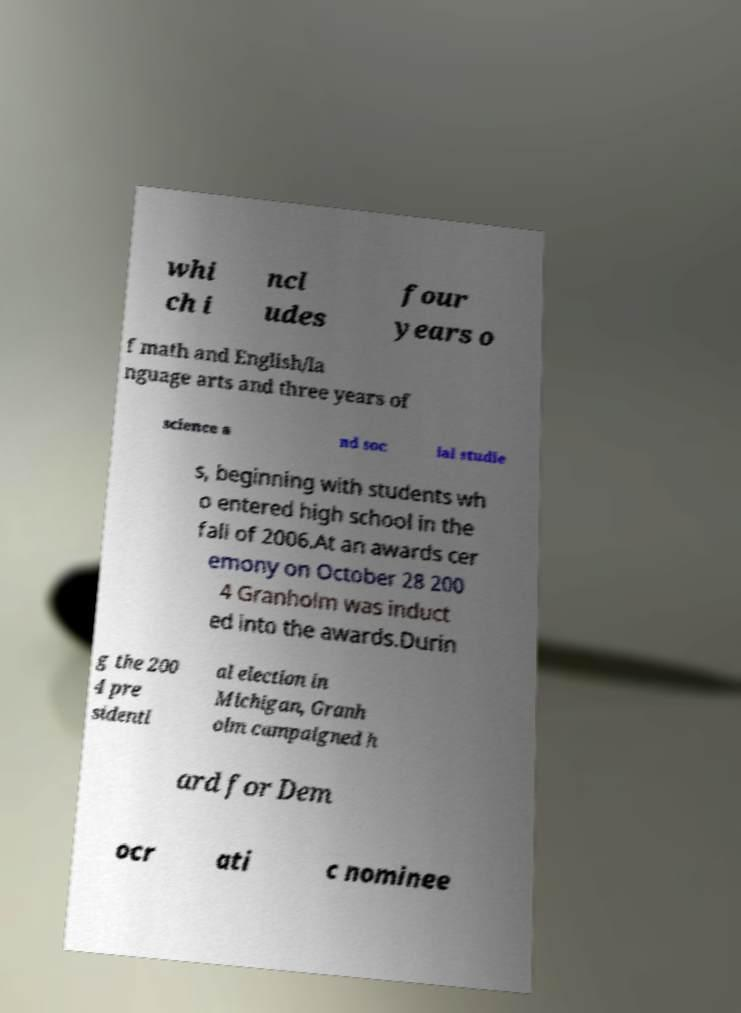For documentation purposes, I need the text within this image transcribed. Could you provide that? whi ch i ncl udes four years o f math and English/la nguage arts and three years of science a nd soc ial studie s, beginning with students wh o entered high school in the fall of 2006.At an awards cer emony on October 28 200 4 Granholm was induct ed into the awards.Durin g the 200 4 pre sidenti al election in Michigan, Granh olm campaigned h ard for Dem ocr ati c nominee 